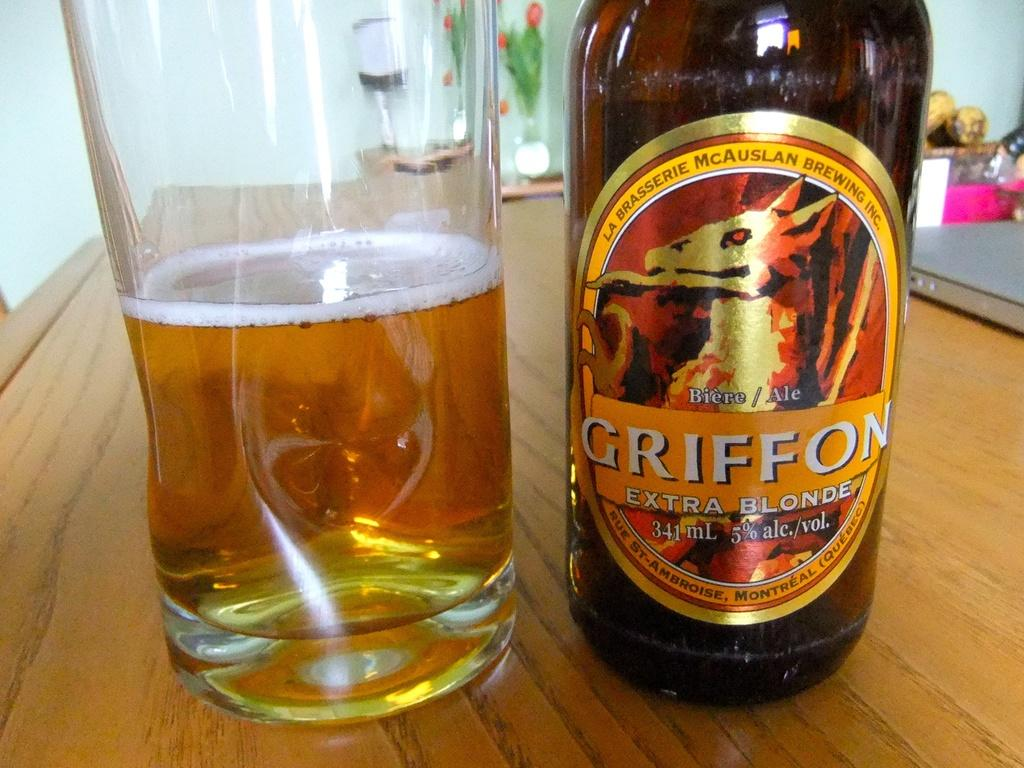Provide a one-sentence caption for the provided image. A bottle labelled Griffon Extra Blonde stands next to a glass. 